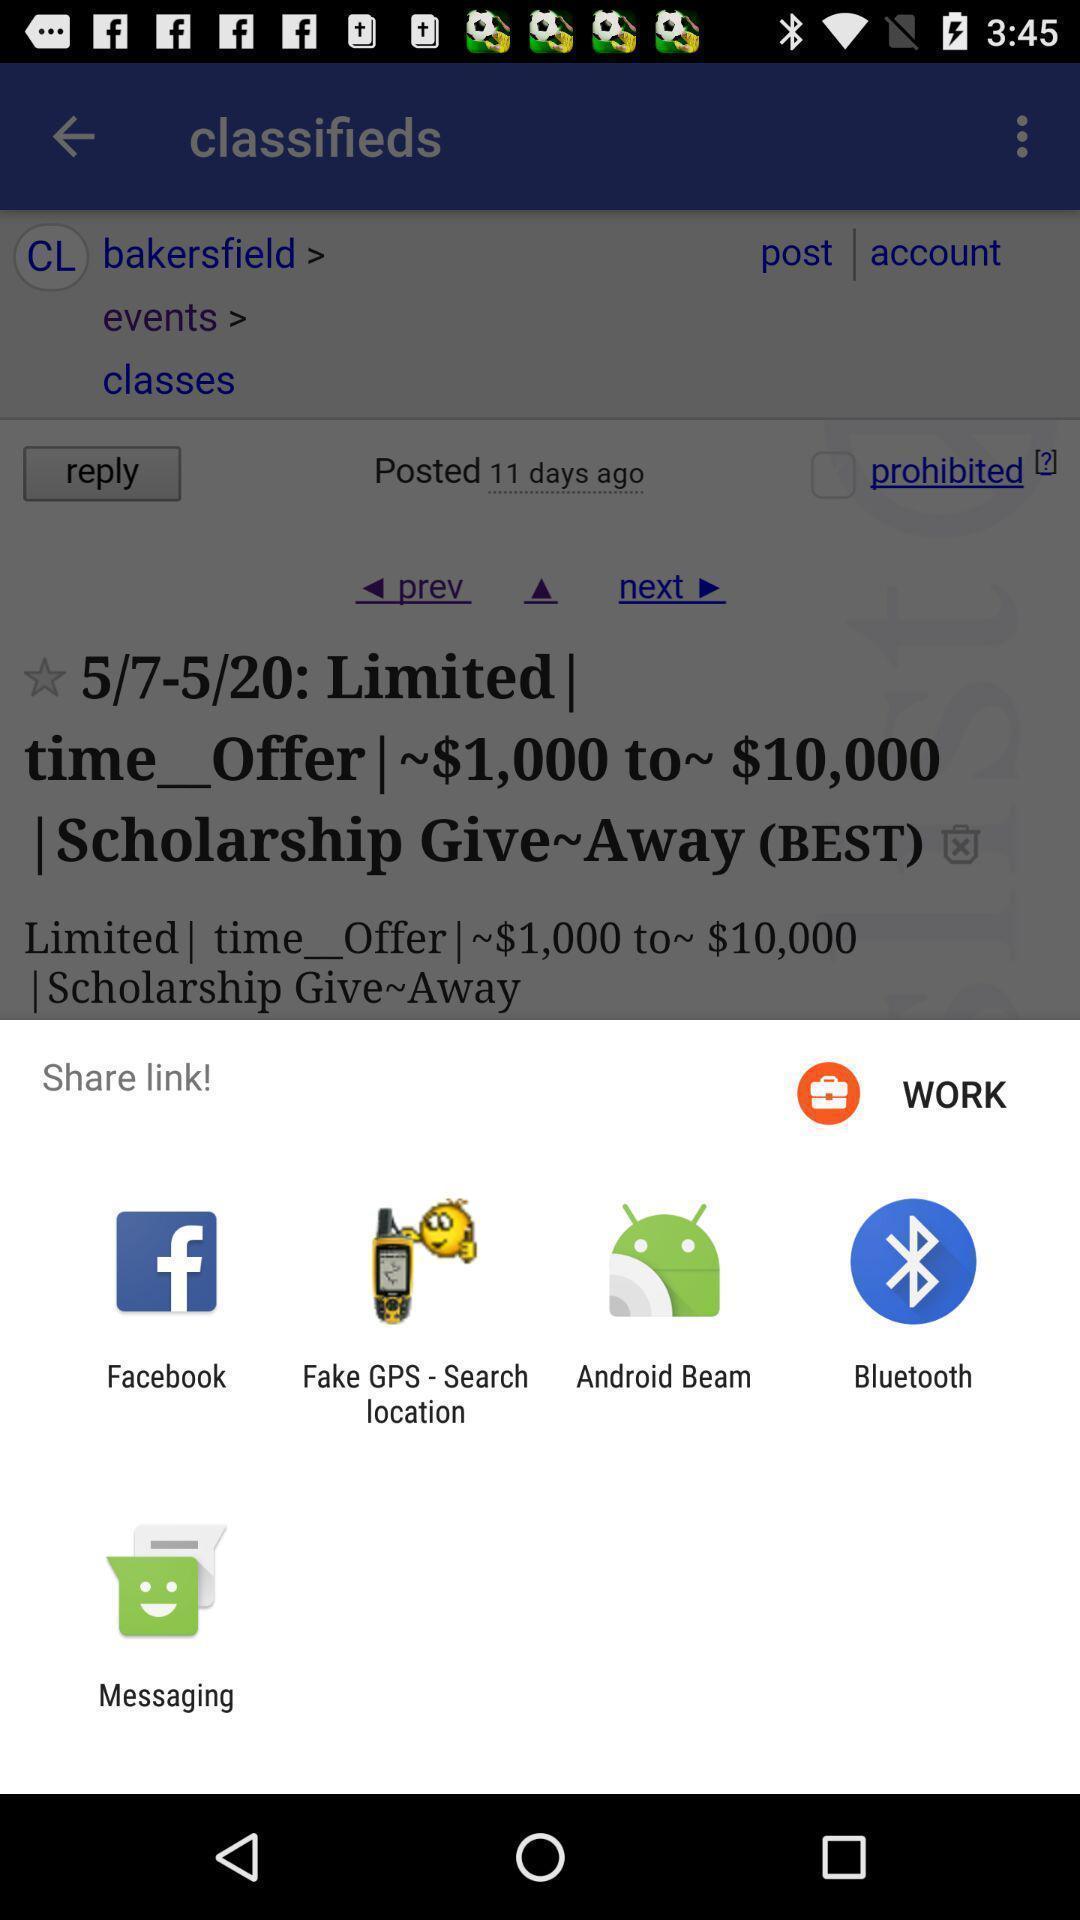Explain the elements present in this screenshot. Pop-up displaying multiple applications to share. 